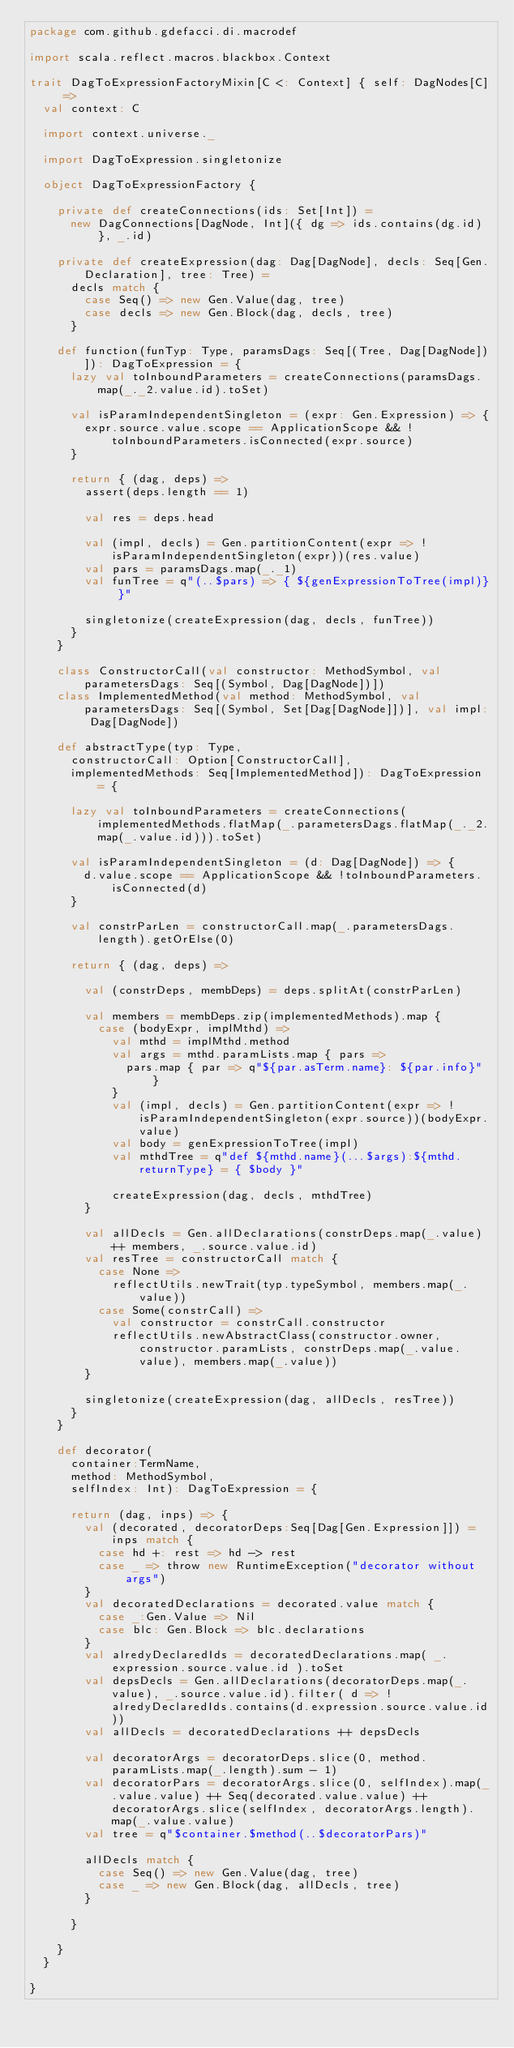Convert code to text. <code><loc_0><loc_0><loc_500><loc_500><_Scala_>package com.github.gdefacci.di.macrodef

import scala.reflect.macros.blackbox.Context

trait DagToExpressionFactoryMixin[C <: Context] { self: DagNodes[C] =>
  val context: C

  import context.universe._

  import DagToExpression.singletonize

  object DagToExpressionFactory {

    private def createConnections(ids: Set[Int]) =
      new DagConnections[DagNode, Int]({ dg => ids.contains(dg.id) }, _.id)

    private def createExpression(dag: Dag[DagNode], decls: Seq[Gen.Declaration], tree: Tree) =
      decls match {
        case Seq() => new Gen.Value(dag, tree)
        case decls => new Gen.Block(dag, decls, tree)
      }

    def function(funTyp: Type, paramsDags: Seq[(Tree, Dag[DagNode])]): DagToExpression = {
      lazy val toInboundParameters = createConnections(paramsDags.map(_._2.value.id).toSet)

      val isParamIndependentSingleton = (expr: Gen.Expression) => {
        expr.source.value.scope == ApplicationScope && !toInboundParameters.isConnected(expr.source)
      }

      return { (dag, deps) =>
        assert(deps.length == 1)

        val res = deps.head

        val (impl, decls) = Gen.partitionContent(expr => !isParamIndependentSingleton(expr))(res.value)
        val pars = paramsDags.map(_._1)
        val funTree = q"(..$pars) => { ${genExpressionToTree(impl)} }"

        singletonize(createExpression(dag, decls, funTree))
      }
    }

    class ConstructorCall(val constructor: MethodSymbol, val parametersDags: Seq[(Symbol, Dag[DagNode])])
    class ImplementedMethod(val method: MethodSymbol, val parametersDags: Seq[(Symbol, Set[Dag[DagNode]])], val impl: Dag[DagNode])

    def abstractType(typ: Type,
      constructorCall: Option[ConstructorCall],
      implementedMethods: Seq[ImplementedMethod]): DagToExpression = {

      lazy val toInboundParameters = createConnections(implementedMethods.flatMap(_.parametersDags.flatMap(_._2.map(_.value.id))).toSet)

      val isParamIndependentSingleton = (d: Dag[DagNode]) => {
        d.value.scope == ApplicationScope && !toInboundParameters.isConnected(d)
      }

      val constrParLen = constructorCall.map(_.parametersDags.length).getOrElse(0)

      return { (dag, deps) =>

        val (constrDeps, membDeps) = deps.splitAt(constrParLen)

        val members = membDeps.zip(implementedMethods).map {
          case (bodyExpr, implMthd) =>
            val mthd = implMthd.method
            val args = mthd.paramLists.map { pars =>
              pars.map { par => q"${par.asTerm.name}: ${par.info}" }
            }
            val (impl, decls) = Gen.partitionContent(expr => !isParamIndependentSingleton(expr.source))(bodyExpr.value)
            val body = genExpressionToTree(impl)
            val mthdTree = q"def ${mthd.name}(...$args):${mthd.returnType} = { $body }"

            createExpression(dag, decls, mthdTree)
        }

        val allDecls = Gen.allDeclarations(constrDeps.map(_.value) ++ members, _.source.value.id)
        val resTree = constructorCall match {
          case None =>
            reflectUtils.newTrait(typ.typeSymbol, members.map(_.value))
          case Some(constrCall) =>
            val constructor = constrCall.constructor
            reflectUtils.newAbstractClass(constructor.owner, constructor.paramLists, constrDeps.map(_.value.value), members.map(_.value))
        }

        singletonize(createExpression(dag, allDecls, resTree))
      }
    }

    def decorator(
      container:TermName,
      method: MethodSymbol,
      selfIndex: Int): DagToExpression = {

      return (dag, inps) => {
        val (decorated, decoratorDeps:Seq[Dag[Gen.Expression]]) = inps match {
          case hd +: rest => hd -> rest
          case _ => throw new RuntimeException("decorator without args") 
        }
        val decoratedDeclarations = decorated.value match {
          case _:Gen.Value => Nil
          case blc: Gen.Block => blc.declarations
        }
        val alredyDeclaredIds = decoratedDeclarations.map( _.expression.source.value.id ).toSet
        val depsDecls = Gen.allDeclarations(decoratorDeps.map(_.value), _.source.value.id).filter( d => !alredyDeclaredIds.contains(d.expression.source.value.id))
        val allDecls = decoratedDeclarations ++ depsDecls
        
        val decoratorArgs = decoratorDeps.slice(0, method.paramLists.map(_.length).sum - 1) 
        val decoratorPars = decoratorArgs.slice(0, selfIndex).map(_.value.value) ++ Seq(decorated.value.value) ++ decoratorArgs.slice(selfIndex, decoratorArgs.length).map(_.value.value)
        val tree = q"$container.$method(..$decoratorPars)"
       
        allDecls match {
          case Seq() => new Gen.Value(dag, tree)
          case _ => new Gen.Block(dag, allDecls, tree)
        }
        
      }

    }
  }

}</code> 